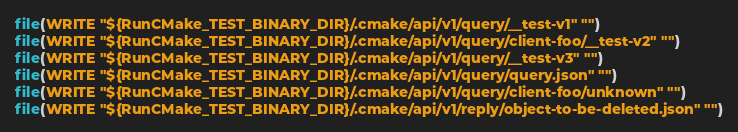Convert code to text. <code><loc_0><loc_0><loc_500><loc_500><_CMake_>file(WRITE "${RunCMake_TEST_BINARY_DIR}/.cmake/api/v1/query/__test-v1" "")
file(WRITE "${RunCMake_TEST_BINARY_DIR}/.cmake/api/v1/query/client-foo/__test-v2" "")
file(WRITE "${RunCMake_TEST_BINARY_DIR}/.cmake/api/v1/query/__test-v3" "")
file(WRITE "${RunCMake_TEST_BINARY_DIR}/.cmake/api/v1/query/query.json" "")
file(WRITE "${RunCMake_TEST_BINARY_DIR}/.cmake/api/v1/query/client-foo/unknown" "")
file(WRITE "${RunCMake_TEST_BINARY_DIR}/.cmake/api/v1/reply/object-to-be-deleted.json" "")
</code> 